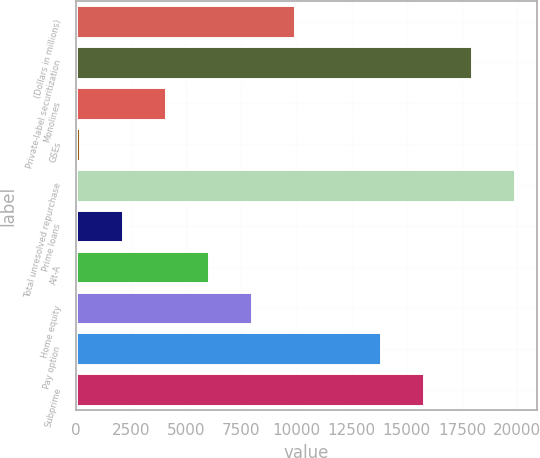Convert chart. <chart><loc_0><loc_0><loc_500><loc_500><bar_chart><fcel>(Dollars in millions)<fcel>Private-label securitization<fcel>Monolines<fcel>GSEs<fcel>Total unresolved repurchase<fcel>Prime loans<fcel>Alt-A<fcel>Home equity<fcel>Pay option<fcel>Subprime<nl><fcel>9912.5<fcel>17953<fcel>4067<fcel>170<fcel>19901.5<fcel>2118.5<fcel>6015.5<fcel>7964<fcel>13809.5<fcel>15758<nl></chart> 